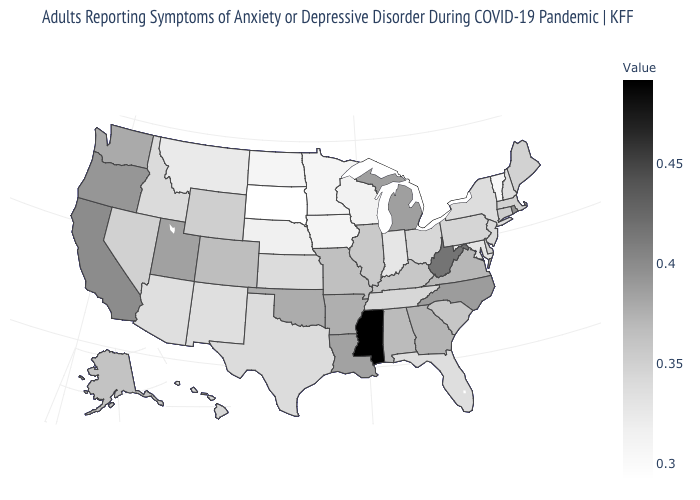Among the states that border Kentucky , which have the lowest value?
Write a very short answer. Indiana. Among the states that border Nevada , which have the lowest value?
Keep it brief. Arizona. Does South Dakota have the lowest value in the USA?
Write a very short answer. Yes. Among the states that border Georgia , which have the lowest value?
Keep it brief. Florida. 